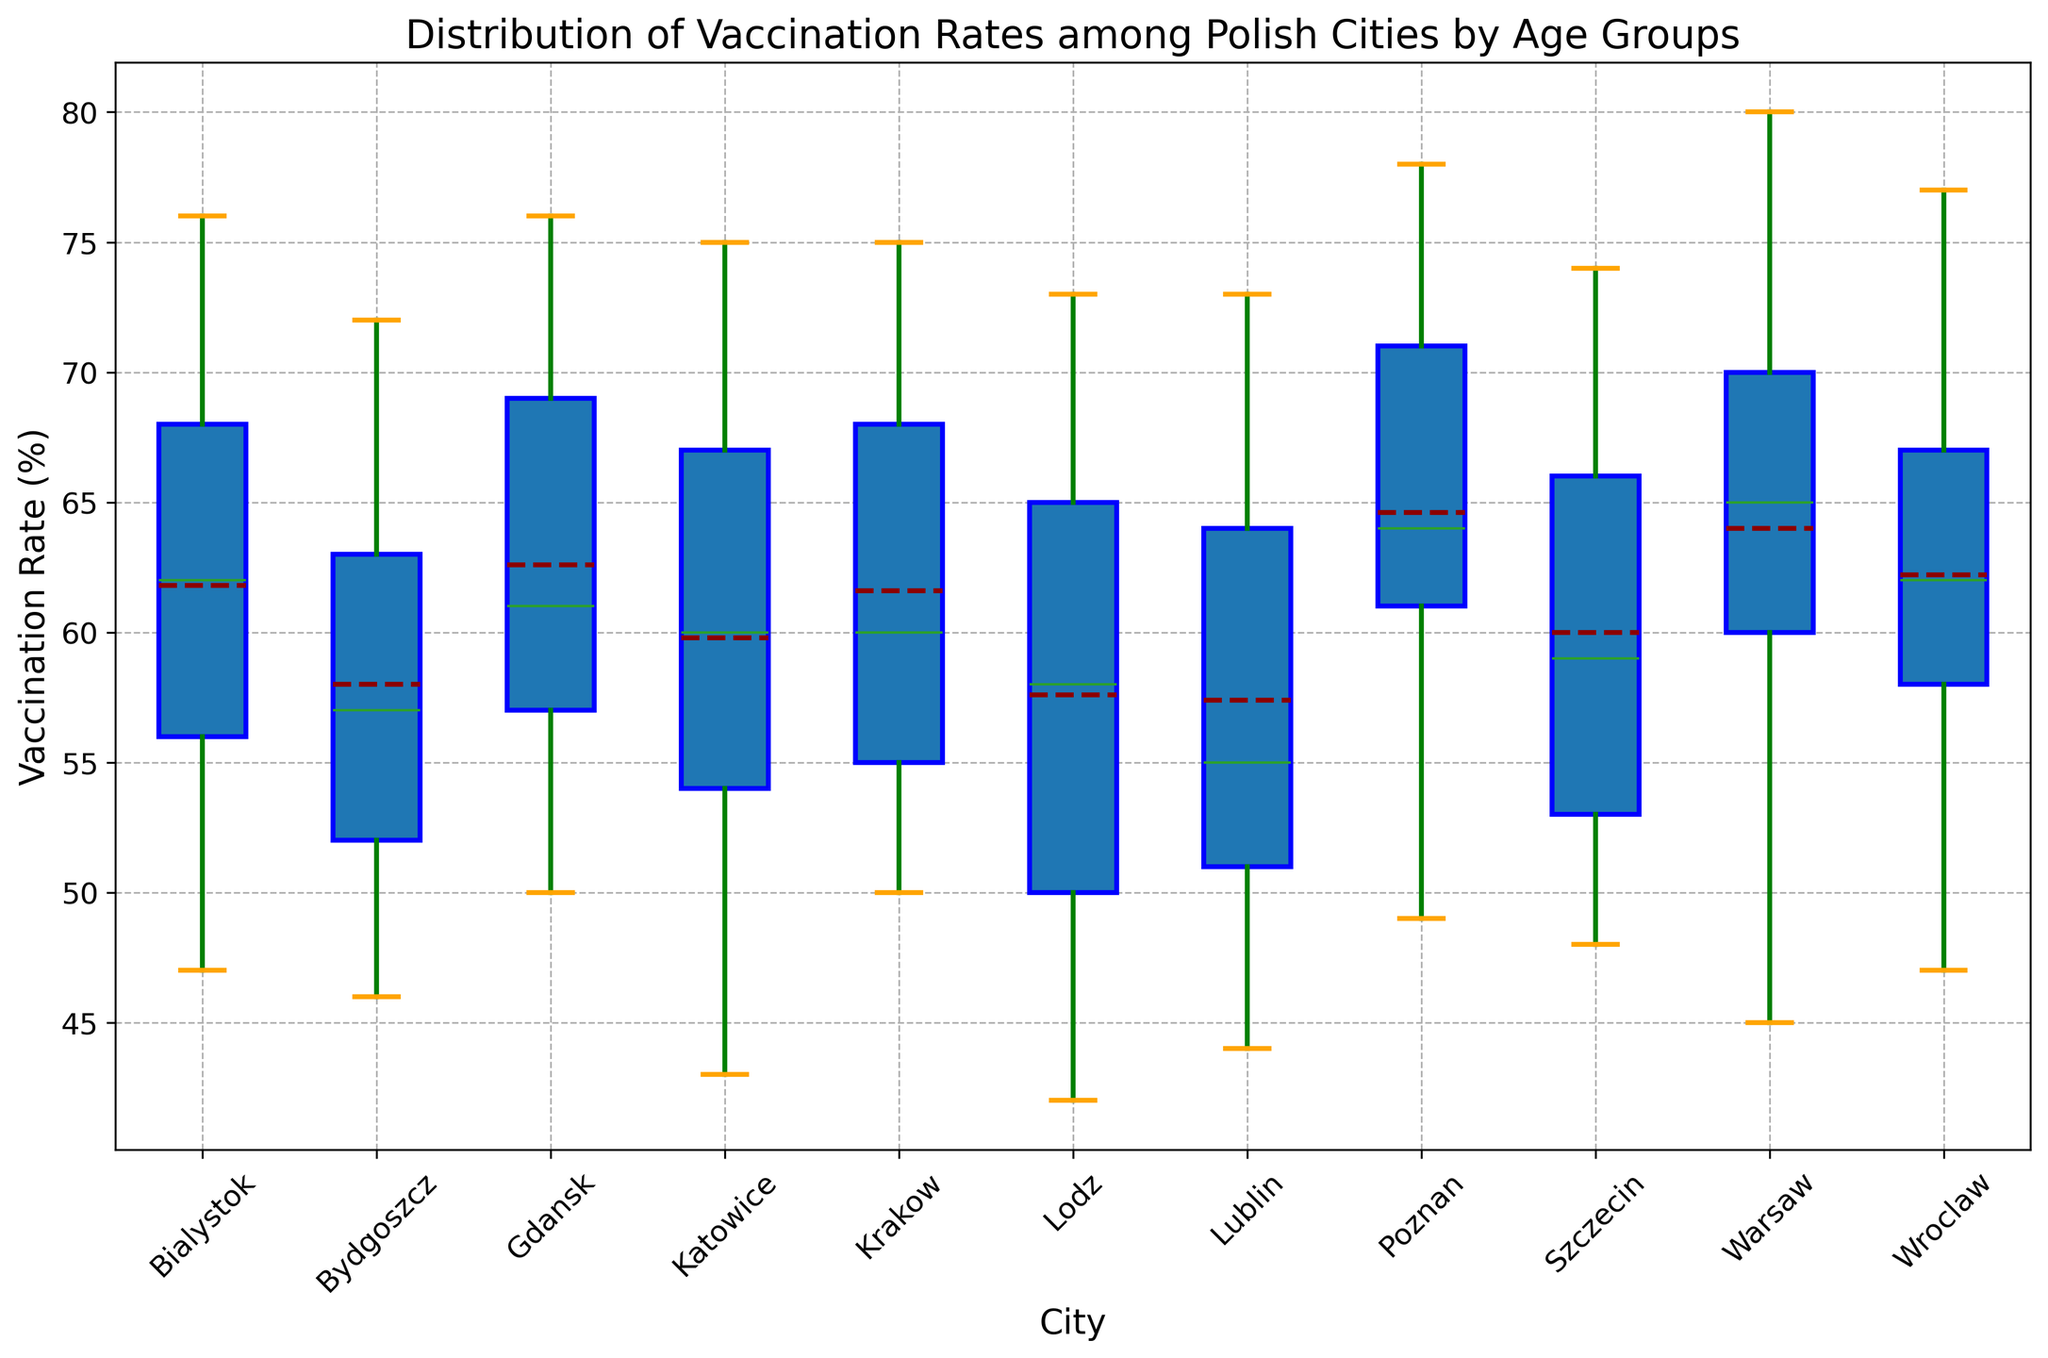Which city has the highest median vaccination rate? The median vaccination rate can be seen as the line inside each box. Comparing these lines, Poznan stands out as having the highest median vaccination rate among the cities.
Answer: Poznan What is the interquartile range (IQR) of vaccination rates in Warsaw? The IQR is the range between the first (lower) quartile and the third (upper) quartile, represented by the top and bottom of the box. In Warsaw's box plot, the upper quartile is around 70%, and the lower quartile is around 45%, making the IQR 70% - 45% = 25%.
Answer: 25% Which city has the largest range of vaccination rates across different age groups? The range is the difference between the maximum and minimum data points. By observing the length of the whiskers and the spread of the data points outside the box, Warsaw shows the largest range with a maximum around 80% and a minimum around 45%, a range of 35%.
Answer: Warsaw For the age group 18-25, which city has the highest vaccination rate? To find this, look at the box plot for the "18-25" age group and identify which city has the topmost whisker or data point. According to the plot, Gdansk and Krakow show the highest mark around 50%.
Answer: Gdansk and Krakow Are there any outliers in the vaccination rates? If so, which city has them? Outliers are often denoted by individual points outside the "whiskers" of the box plot. There are no such data points outside the whiskers in this plot, indicating there are no outliers.
Answer: None What is the vaccination rate in Lodz for the age group 61+? For this, examine the box plot section for "61+" and identify the plotting point or end of the whisker corresponding to Lodz. The plot shows the rate at approximately 73%.
Answer: 73% Which city shows the lowest mean vaccination rate across all age groups? The mean is usually marked by a line inside the boxes. By comparing the mean lines across the plots, Lublin appears to have the lowest mean rate as it's closer to the bottom across all age groups.
Answer: Lublin 